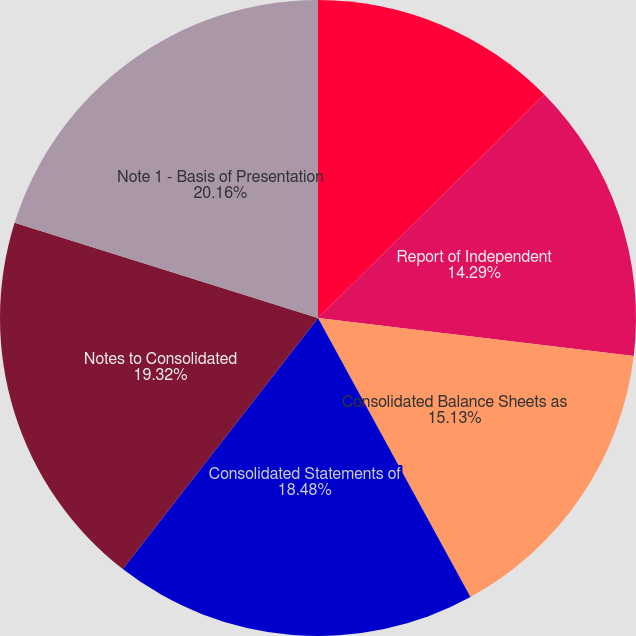<chart> <loc_0><loc_0><loc_500><loc_500><pie_chart><fcel>Report of Management on<fcel>Report of Independent<fcel>Consolidated Balance Sheets as<fcel>Consolidated Statements of<fcel>Notes to Consolidated<fcel>Note 1 - Basis of Presentation<nl><fcel>12.62%<fcel>14.29%<fcel>15.13%<fcel>18.48%<fcel>19.32%<fcel>20.16%<nl></chart> 